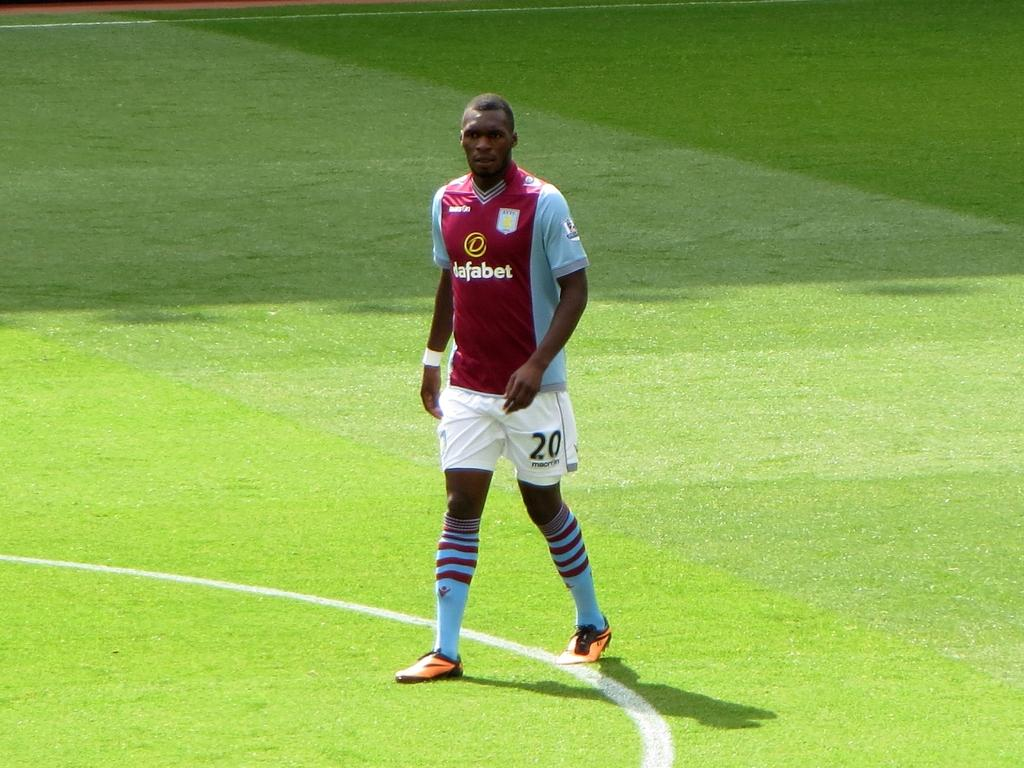Provide a one-sentence caption for the provided image. A soccer player, with white shorts bearing the number 20, stands on a field. 